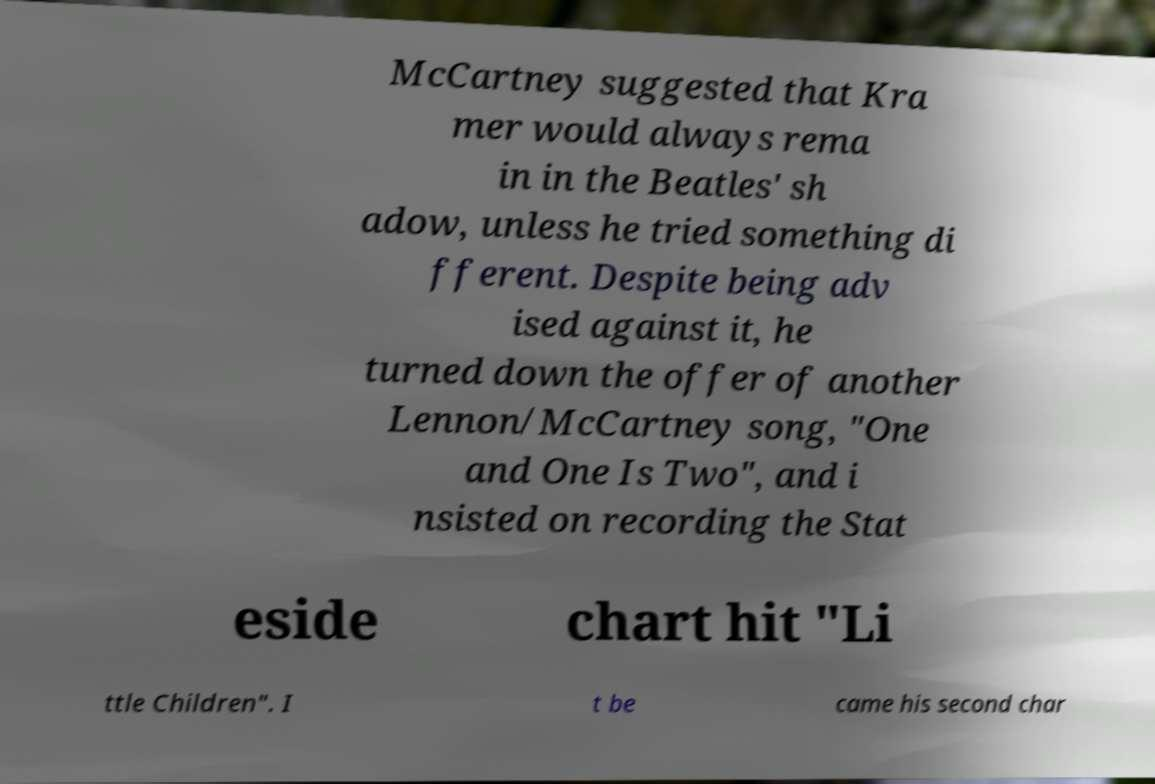Can you read and provide the text displayed in the image?This photo seems to have some interesting text. Can you extract and type it out for me? McCartney suggested that Kra mer would always rema in in the Beatles' sh adow, unless he tried something di fferent. Despite being adv ised against it, he turned down the offer of another Lennon/McCartney song, "One and One Is Two", and i nsisted on recording the Stat eside chart hit "Li ttle Children". I t be came his second char 